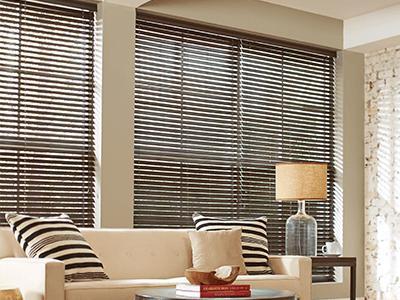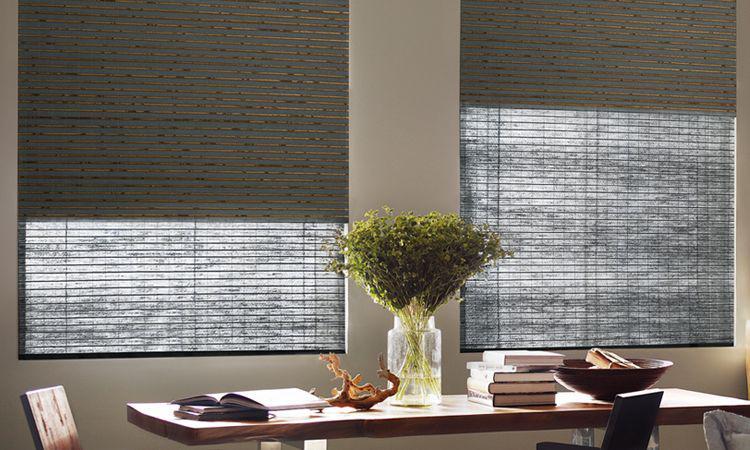The first image is the image on the left, the second image is the image on the right. Evaluate the accuracy of this statement regarding the images: "In the image to the left, the slats of the window shade are not completely closed; you can still see a little bit of light.". Is it true? Answer yes or no. Yes. The first image is the image on the left, the second image is the image on the right. Evaluate the accuracy of this statement regarding the images: "The left and right image contains a total of five blinds.". Is it true? Answer yes or no. Yes. 